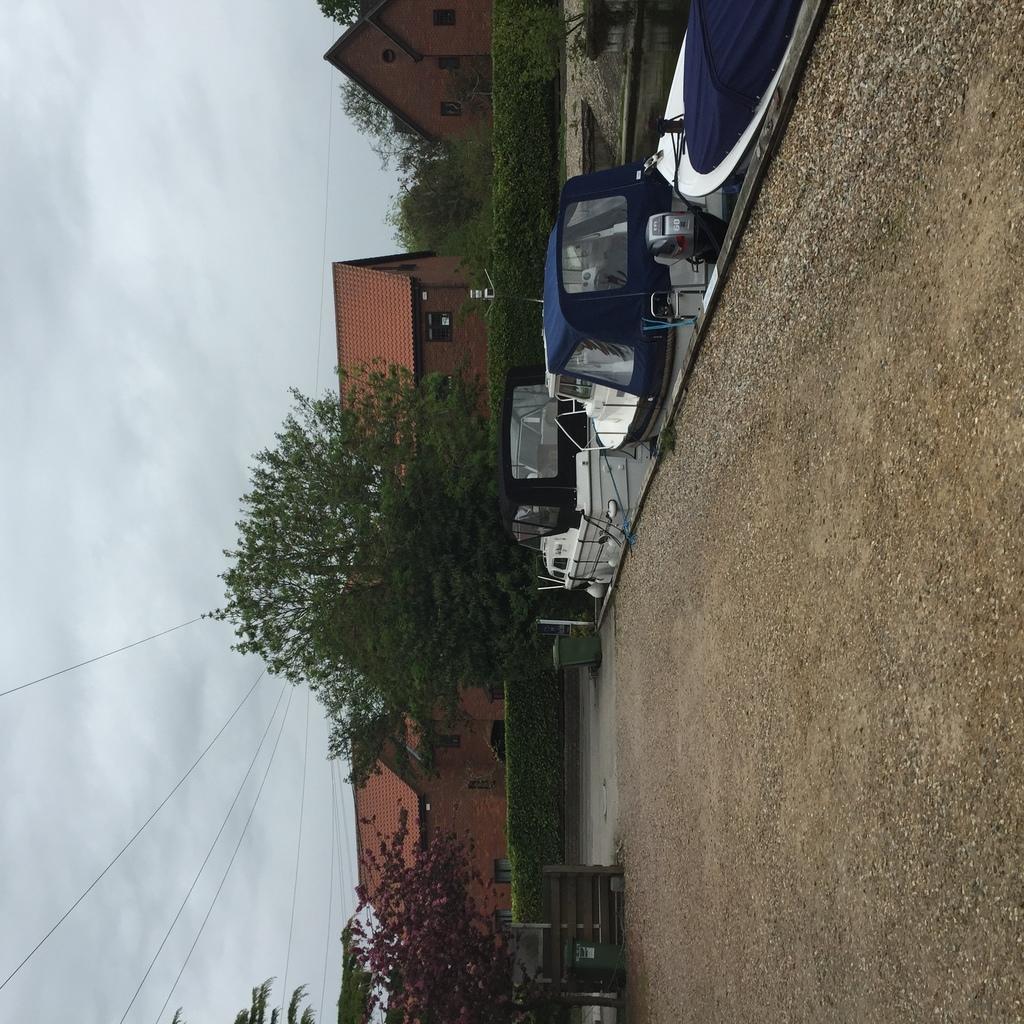Describe this image in one or two sentences. In this image at the top of the image there are some boats, and in the center there are some houses, trees and some plants, dustbin, fence. And on the left side of the image there is sky, and on the right side of the image there is sand. 